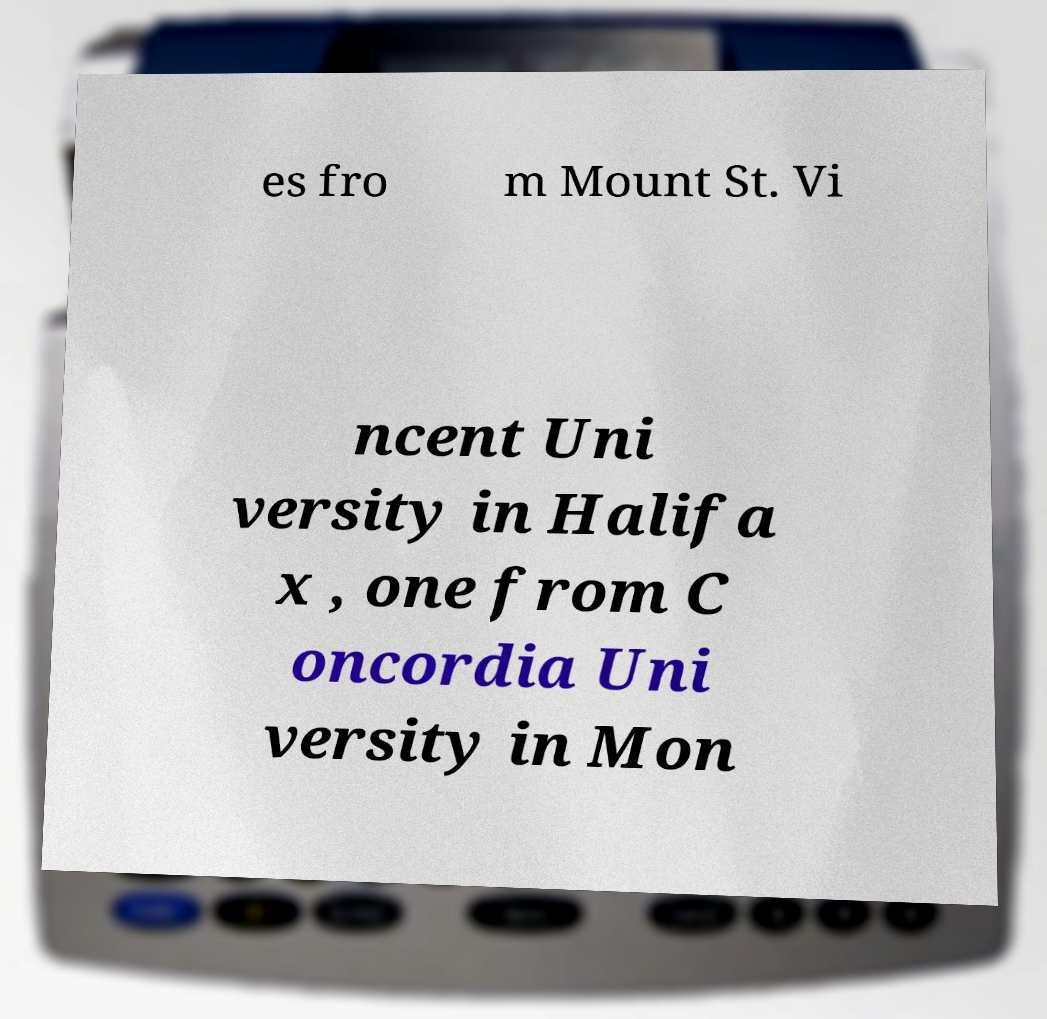Can you read and provide the text displayed in the image?This photo seems to have some interesting text. Can you extract and type it out for me? es fro m Mount St. Vi ncent Uni versity in Halifa x , one from C oncordia Uni versity in Mon 